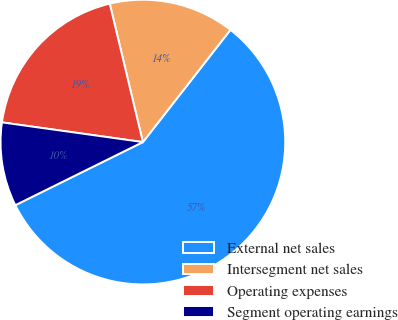<chart> <loc_0><loc_0><loc_500><loc_500><pie_chart><fcel>External net sales<fcel>Intersegment net sales<fcel>Operating expenses<fcel>Segment operating earnings<nl><fcel>57.15%<fcel>14.28%<fcel>19.05%<fcel>9.52%<nl></chart> 